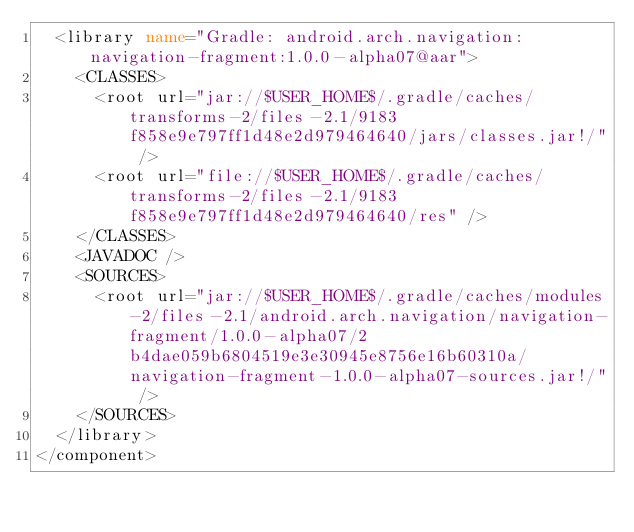Convert code to text. <code><loc_0><loc_0><loc_500><loc_500><_XML_>  <library name="Gradle: android.arch.navigation:navigation-fragment:1.0.0-alpha07@aar">
    <CLASSES>
      <root url="jar://$USER_HOME$/.gradle/caches/transforms-2/files-2.1/9183f858e9e797ff1d48e2d979464640/jars/classes.jar!/" />
      <root url="file://$USER_HOME$/.gradle/caches/transforms-2/files-2.1/9183f858e9e797ff1d48e2d979464640/res" />
    </CLASSES>
    <JAVADOC />
    <SOURCES>
      <root url="jar://$USER_HOME$/.gradle/caches/modules-2/files-2.1/android.arch.navigation/navigation-fragment/1.0.0-alpha07/2b4dae059b6804519e3e30945e8756e16b60310a/navigation-fragment-1.0.0-alpha07-sources.jar!/" />
    </SOURCES>
  </library>
</component></code> 